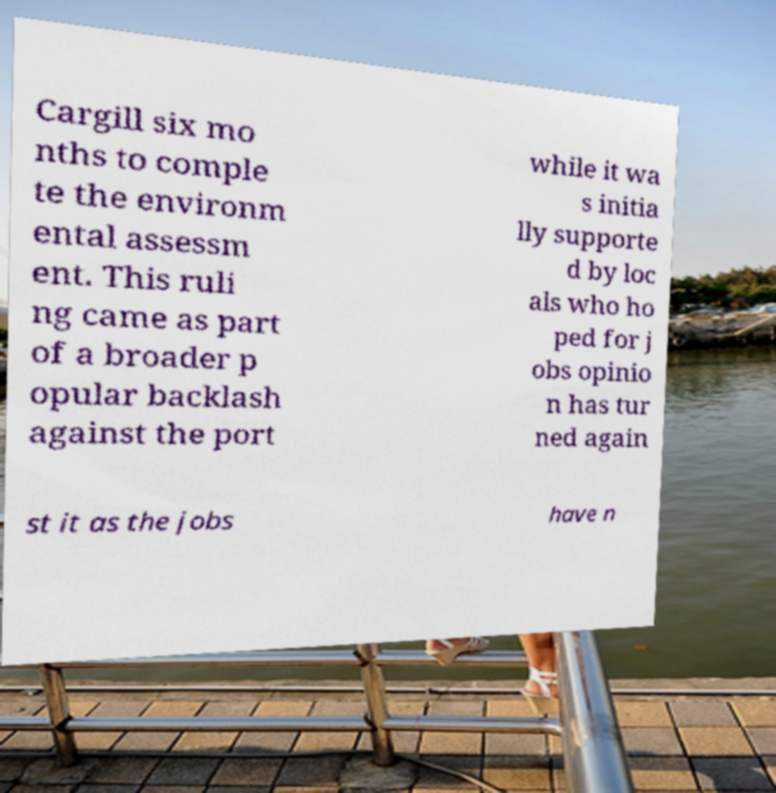For documentation purposes, I need the text within this image transcribed. Could you provide that? Cargill six mo nths to comple te the environm ental assessm ent. This ruli ng came as part of a broader p opular backlash against the port while it wa s initia lly supporte d by loc als who ho ped for j obs opinio n has tur ned again st it as the jobs have n 